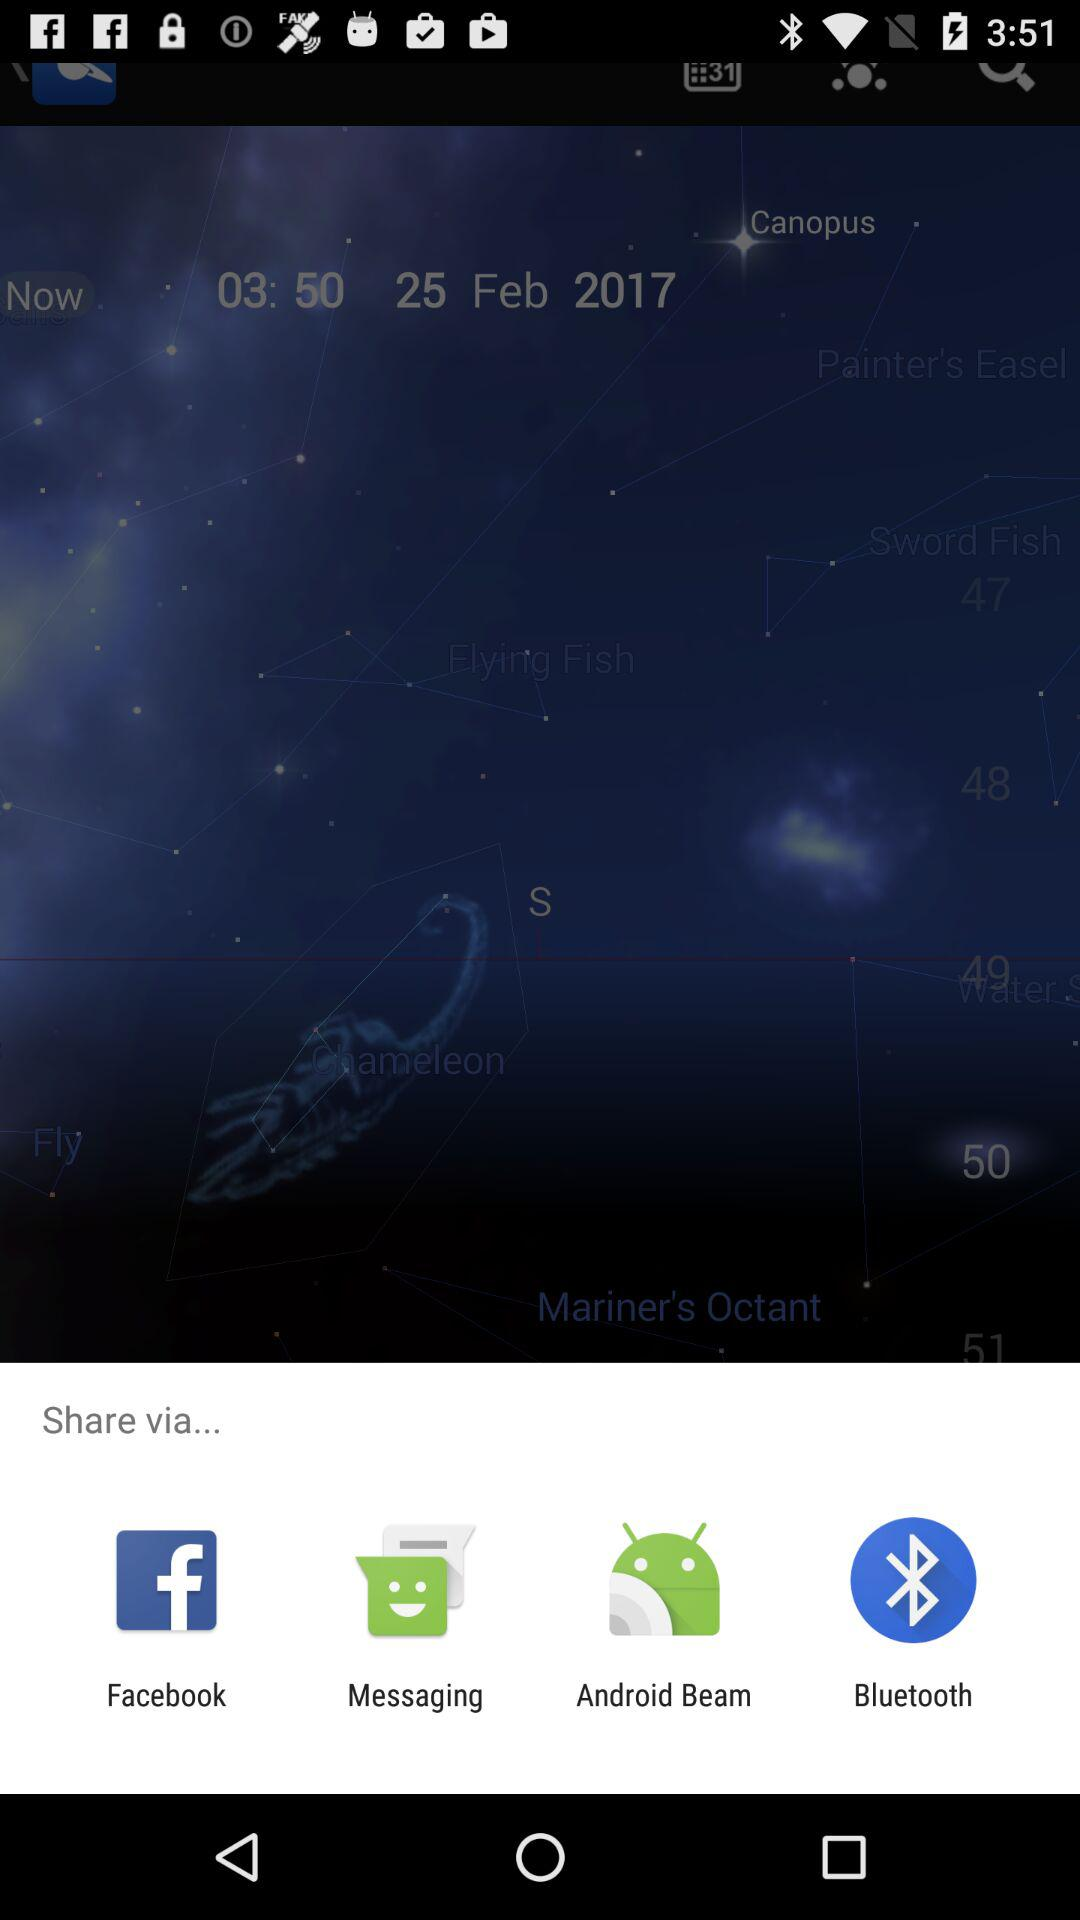What are the different options available for sharing? The different options available for sharing are "Facebook", "Messaging", "Android Beam" and "Bluetooth". 